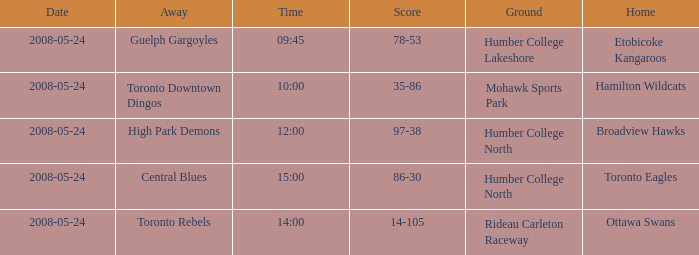On what day was the game that ended in a score of 97-38? 2008-05-24. 